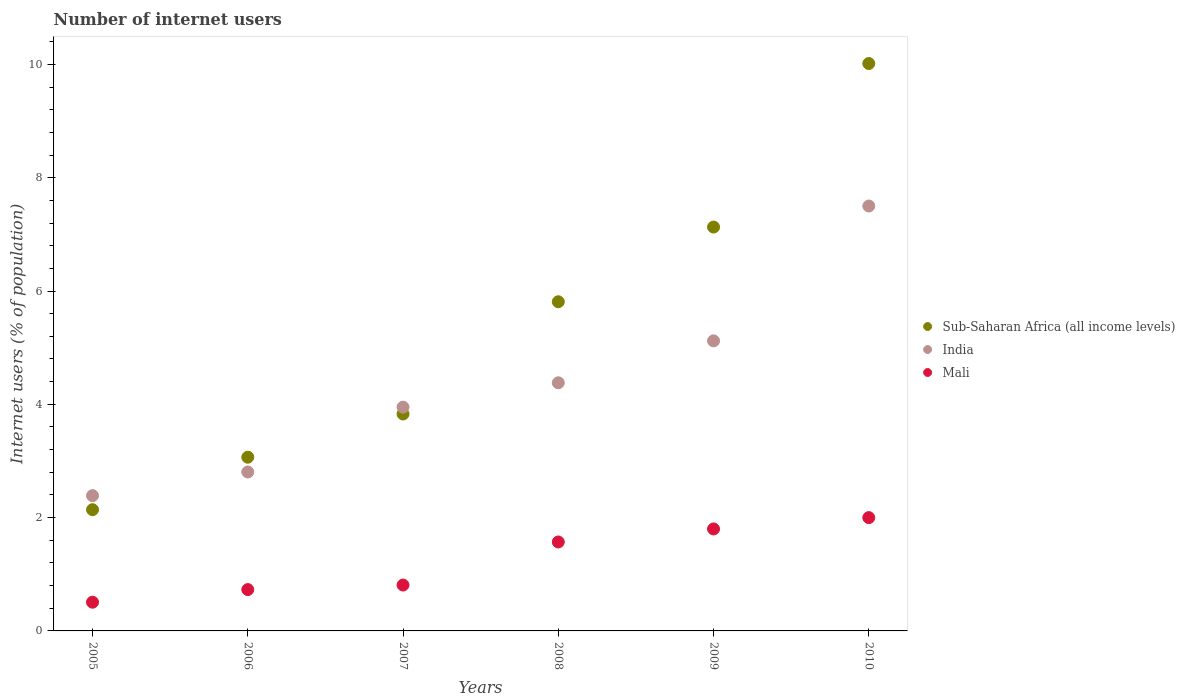How many different coloured dotlines are there?
Ensure brevity in your answer.  3. Is the number of dotlines equal to the number of legend labels?
Offer a very short reply. Yes. What is the number of internet users in India in 2005?
Offer a very short reply. 2.39. Across all years, what is the maximum number of internet users in Sub-Saharan Africa (all income levels)?
Give a very brief answer. 10.02. Across all years, what is the minimum number of internet users in Sub-Saharan Africa (all income levels)?
Your answer should be compact. 2.14. In which year was the number of internet users in Sub-Saharan Africa (all income levels) maximum?
Your answer should be very brief. 2010. In which year was the number of internet users in India minimum?
Your answer should be very brief. 2005. What is the total number of internet users in India in the graph?
Your response must be concise. 26.14. What is the difference between the number of internet users in India in 2009 and that in 2010?
Give a very brief answer. -2.38. What is the difference between the number of internet users in Mali in 2005 and the number of internet users in India in 2009?
Provide a succinct answer. -4.61. What is the average number of internet users in India per year?
Your answer should be compact. 4.36. In the year 2006, what is the difference between the number of internet users in India and number of internet users in Sub-Saharan Africa (all income levels)?
Make the answer very short. -0.26. What is the ratio of the number of internet users in Sub-Saharan Africa (all income levels) in 2006 to that in 2008?
Provide a short and direct response. 0.53. Is the number of internet users in Mali in 2006 less than that in 2010?
Make the answer very short. Yes. What is the difference between the highest and the second highest number of internet users in Sub-Saharan Africa (all income levels)?
Make the answer very short. 2.89. What is the difference between the highest and the lowest number of internet users in Mali?
Your answer should be very brief. 1.49. Is the sum of the number of internet users in Sub-Saharan Africa (all income levels) in 2008 and 2009 greater than the maximum number of internet users in Mali across all years?
Provide a succinct answer. Yes. Does the number of internet users in Sub-Saharan Africa (all income levels) monotonically increase over the years?
Your answer should be compact. Yes. Are the values on the major ticks of Y-axis written in scientific E-notation?
Keep it short and to the point. No. Does the graph contain any zero values?
Keep it short and to the point. No. Where does the legend appear in the graph?
Your response must be concise. Center right. How many legend labels are there?
Provide a short and direct response. 3. How are the legend labels stacked?
Your response must be concise. Vertical. What is the title of the graph?
Provide a succinct answer. Number of internet users. Does "Samoa" appear as one of the legend labels in the graph?
Provide a short and direct response. No. What is the label or title of the X-axis?
Your response must be concise. Years. What is the label or title of the Y-axis?
Your response must be concise. Internet users (% of population). What is the Internet users (% of population) in Sub-Saharan Africa (all income levels) in 2005?
Ensure brevity in your answer.  2.14. What is the Internet users (% of population) of India in 2005?
Give a very brief answer. 2.39. What is the Internet users (% of population) of Mali in 2005?
Your answer should be very brief. 0.51. What is the Internet users (% of population) in Sub-Saharan Africa (all income levels) in 2006?
Offer a terse response. 3.07. What is the Internet users (% of population) in India in 2006?
Keep it short and to the point. 2.81. What is the Internet users (% of population) in Mali in 2006?
Make the answer very short. 0.73. What is the Internet users (% of population) in Sub-Saharan Africa (all income levels) in 2007?
Ensure brevity in your answer.  3.83. What is the Internet users (% of population) in India in 2007?
Make the answer very short. 3.95. What is the Internet users (% of population) of Mali in 2007?
Provide a succinct answer. 0.81. What is the Internet users (% of population) in Sub-Saharan Africa (all income levels) in 2008?
Ensure brevity in your answer.  5.81. What is the Internet users (% of population) of India in 2008?
Your answer should be very brief. 4.38. What is the Internet users (% of population) in Mali in 2008?
Ensure brevity in your answer.  1.57. What is the Internet users (% of population) in Sub-Saharan Africa (all income levels) in 2009?
Ensure brevity in your answer.  7.13. What is the Internet users (% of population) in India in 2009?
Offer a terse response. 5.12. What is the Internet users (% of population) of Sub-Saharan Africa (all income levels) in 2010?
Provide a short and direct response. 10.02. What is the Internet users (% of population) in Mali in 2010?
Ensure brevity in your answer.  2. Across all years, what is the maximum Internet users (% of population) in Sub-Saharan Africa (all income levels)?
Your answer should be compact. 10.02. Across all years, what is the minimum Internet users (% of population) in Sub-Saharan Africa (all income levels)?
Your answer should be very brief. 2.14. Across all years, what is the minimum Internet users (% of population) in India?
Your answer should be compact. 2.39. Across all years, what is the minimum Internet users (% of population) of Mali?
Offer a terse response. 0.51. What is the total Internet users (% of population) of Sub-Saharan Africa (all income levels) in the graph?
Your response must be concise. 31.99. What is the total Internet users (% of population) of India in the graph?
Offer a very short reply. 26.14. What is the total Internet users (% of population) of Mali in the graph?
Keep it short and to the point. 7.42. What is the difference between the Internet users (% of population) in Sub-Saharan Africa (all income levels) in 2005 and that in 2006?
Provide a short and direct response. -0.93. What is the difference between the Internet users (% of population) of India in 2005 and that in 2006?
Your response must be concise. -0.42. What is the difference between the Internet users (% of population) of Mali in 2005 and that in 2006?
Ensure brevity in your answer.  -0.22. What is the difference between the Internet users (% of population) in Sub-Saharan Africa (all income levels) in 2005 and that in 2007?
Provide a succinct answer. -1.69. What is the difference between the Internet users (% of population) in India in 2005 and that in 2007?
Your answer should be very brief. -1.56. What is the difference between the Internet users (% of population) of Mali in 2005 and that in 2007?
Keep it short and to the point. -0.3. What is the difference between the Internet users (% of population) in Sub-Saharan Africa (all income levels) in 2005 and that in 2008?
Give a very brief answer. -3.67. What is the difference between the Internet users (% of population) in India in 2005 and that in 2008?
Make the answer very short. -1.99. What is the difference between the Internet users (% of population) in Mali in 2005 and that in 2008?
Make the answer very short. -1.06. What is the difference between the Internet users (% of population) of Sub-Saharan Africa (all income levels) in 2005 and that in 2009?
Your response must be concise. -4.99. What is the difference between the Internet users (% of population) in India in 2005 and that in 2009?
Ensure brevity in your answer.  -2.73. What is the difference between the Internet users (% of population) in Mali in 2005 and that in 2009?
Offer a terse response. -1.29. What is the difference between the Internet users (% of population) in Sub-Saharan Africa (all income levels) in 2005 and that in 2010?
Your answer should be very brief. -7.88. What is the difference between the Internet users (% of population) of India in 2005 and that in 2010?
Give a very brief answer. -5.11. What is the difference between the Internet users (% of population) in Mali in 2005 and that in 2010?
Give a very brief answer. -1.49. What is the difference between the Internet users (% of population) of Sub-Saharan Africa (all income levels) in 2006 and that in 2007?
Your answer should be compact. -0.76. What is the difference between the Internet users (% of population) of India in 2006 and that in 2007?
Provide a succinct answer. -1.14. What is the difference between the Internet users (% of population) in Mali in 2006 and that in 2007?
Give a very brief answer. -0.08. What is the difference between the Internet users (% of population) in Sub-Saharan Africa (all income levels) in 2006 and that in 2008?
Your answer should be compact. -2.74. What is the difference between the Internet users (% of population) in India in 2006 and that in 2008?
Keep it short and to the point. -1.57. What is the difference between the Internet users (% of population) of Mali in 2006 and that in 2008?
Offer a terse response. -0.84. What is the difference between the Internet users (% of population) of Sub-Saharan Africa (all income levels) in 2006 and that in 2009?
Ensure brevity in your answer.  -4.06. What is the difference between the Internet users (% of population) of India in 2006 and that in 2009?
Give a very brief answer. -2.31. What is the difference between the Internet users (% of population) of Mali in 2006 and that in 2009?
Provide a succinct answer. -1.07. What is the difference between the Internet users (% of population) in Sub-Saharan Africa (all income levels) in 2006 and that in 2010?
Your answer should be very brief. -6.95. What is the difference between the Internet users (% of population) of India in 2006 and that in 2010?
Provide a short and direct response. -4.69. What is the difference between the Internet users (% of population) in Mali in 2006 and that in 2010?
Offer a very short reply. -1.27. What is the difference between the Internet users (% of population) of Sub-Saharan Africa (all income levels) in 2007 and that in 2008?
Your answer should be very brief. -1.98. What is the difference between the Internet users (% of population) in India in 2007 and that in 2008?
Provide a succinct answer. -0.43. What is the difference between the Internet users (% of population) in Mali in 2007 and that in 2008?
Your answer should be very brief. -0.76. What is the difference between the Internet users (% of population) in Sub-Saharan Africa (all income levels) in 2007 and that in 2009?
Ensure brevity in your answer.  -3.3. What is the difference between the Internet users (% of population) of India in 2007 and that in 2009?
Provide a short and direct response. -1.17. What is the difference between the Internet users (% of population) of Mali in 2007 and that in 2009?
Make the answer very short. -0.99. What is the difference between the Internet users (% of population) of Sub-Saharan Africa (all income levels) in 2007 and that in 2010?
Ensure brevity in your answer.  -6.19. What is the difference between the Internet users (% of population) in India in 2007 and that in 2010?
Provide a succinct answer. -3.55. What is the difference between the Internet users (% of population) of Mali in 2007 and that in 2010?
Offer a terse response. -1.19. What is the difference between the Internet users (% of population) in Sub-Saharan Africa (all income levels) in 2008 and that in 2009?
Ensure brevity in your answer.  -1.32. What is the difference between the Internet users (% of population) in India in 2008 and that in 2009?
Your answer should be very brief. -0.74. What is the difference between the Internet users (% of population) in Mali in 2008 and that in 2009?
Make the answer very short. -0.23. What is the difference between the Internet users (% of population) of Sub-Saharan Africa (all income levels) in 2008 and that in 2010?
Your answer should be very brief. -4.21. What is the difference between the Internet users (% of population) in India in 2008 and that in 2010?
Your answer should be very brief. -3.12. What is the difference between the Internet users (% of population) in Mali in 2008 and that in 2010?
Your answer should be compact. -0.43. What is the difference between the Internet users (% of population) in Sub-Saharan Africa (all income levels) in 2009 and that in 2010?
Make the answer very short. -2.89. What is the difference between the Internet users (% of population) in India in 2009 and that in 2010?
Provide a short and direct response. -2.38. What is the difference between the Internet users (% of population) in Mali in 2009 and that in 2010?
Ensure brevity in your answer.  -0.2. What is the difference between the Internet users (% of population) of Sub-Saharan Africa (all income levels) in 2005 and the Internet users (% of population) of India in 2006?
Keep it short and to the point. -0.67. What is the difference between the Internet users (% of population) in Sub-Saharan Africa (all income levels) in 2005 and the Internet users (% of population) in Mali in 2006?
Your answer should be compact. 1.41. What is the difference between the Internet users (% of population) of India in 2005 and the Internet users (% of population) of Mali in 2006?
Provide a succinct answer. 1.66. What is the difference between the Internet users (% of population) of Sub-Saharan Africa (all income levels) in 2005 and the Internet users (% of population) of India in 2007?
Your answer should be very brief. -1.81. What is the difference between the Internet users (% of population) of Sub-Saharan Africa (all income levels) in 2005 and the Internet users (% of population) of Mali in 2007?
Your response must be concise. 1.33. What is the difference between the Internet users (% of population) of India in 2005 and the Internet users (% of population) of Mali in 2007?
Ensure brevity in your answer.  1.58. What is the difference between the Internet users (% of population) in Sub-Saharan Africa (all income levels) in 2005 and the Internet users (% of population) in India in 2008?
Ensure brevity in your answer.  -2.24. What is the difference between the Internet users (% of population) in Sub-Saharan Africa (all income levels) in 2005 and the Internet users (% of population) in Mali in 2008?
Give a very brief answer. 0.57. What is the difference between the Internet users (% of population) in India in 2005 and the Internet users (% of population) in Mali in 2008?
Make the answer very short. 0.82. What is the difference between the Internet users (% of population) of Sub-Saharan Africa (all income levels) in 2005 and the Internet users (% of population) of India in 2009?
Make the answer very short. -2.98. What is the difference between the Internet users (% of population) in Sub-Saharan Africa (all income levels) in 2005 and the Internet users (% of population) in Mali in 2009?
Provide a succinct answer. 0.34. What is the difference between the Internet users (% of population) of India in 2005 and the Internet users (% of population) of Mali in 2009?
Provide a short and direct response. 0.59. What is the difference between the Internet users (% of population) of Sub-Saharan Africa (all income levels) in 2005 and the Internet users (% of population) of India in 2010?
Your response must be concise. -5.36. What is the difference between the Internet users (% of population) of Sub-Saharan Africa (all income levels) in 2005 and the Internet users (% of population) of Mali in 2010?
Provide a short and direct response. 0.14. What is the difference between the Internet users (% of population) in India in 2005 and the Internet users (% of population) in Mali in 2010?
Provide a succinct answer. 0.39. What is the difference between the Internet users (% of population) of Sub-Saharan Africa (all income levels) in 2006 and the Internet users (% of population) of India in 2007?
Provide a short and direct response. -0.88. What is the difference between the Internet users (% of population) in Sub-Saharan Africa (all income levels) in 2006 and the Internet users (% of population) in Mali in 2007?
Keep it short and to the point. 2.26. What is the difference between the Internet users (% of population) of India in 2006 and the Internet users (% of population) of Mali in 2007?
Ensure brevity in your answer.  2. What is the difference between the Internet users (% of population) of Sub-Saharan Africa (all income levels) in 2006 and the Internet users (% of population) of India in 2008?
Your answer should be very brief. -1.31. What is the difference between the Internet users (% of population) in Sub-Saharan Africa (all income levels) in 2006 and the Internet users (% of population) in Mali in 2008?
Provide a succinct answer. 1.5. What is the difference between the Internet users (% of population) of India in 2006 and the Internet users (% of population) of Mali in 2008?
Keep it short and to the point. 1.24. What is the difference between the Internet users (% of population) in Sub-Saharan Africa (all income levels) in 2006 and the Internet users (% of population) in India in 2009?
Give a very brief answer. -2.05. What is the difference between the Internet users (% of population) of Sub-Saharan Africa (all income levels) in 2006 and the Internet users (% of population) of Mali in 2009?
Keep it short and to the point. 1.27. What is the difference between the Internet users (% of population) in Sub-Saharan Africa (all income levels) in 2006 and the Internet users (% of population) in India in 2010?
Offer a very short reply. -4.43. What is the difference between the Internet users (% of population) in Sub-Saharan Africa (all income levels) in 2006 and the Internet users (% of population) in Mali in 2010?
Ensure brevity in your answer.  1.07. What is the difference between the Internet users (% of population) in India in 2006 and the Internet users (% of population) in Mali in 2010?
Offer a terse response. 0.81. What is the difference between the Internet users (% of population) of Sub-Saharan Africa (all income levels) in 2007 and the Internet users (% of population) of India in 2008?
Your response must be concise. -0.55. What is the difference between the Internet users (% of population) in Sub-Saharan Africa (all income levels) in 2007 and the Internet users (% of population) in Mali in 2008?
Keep it short and to the point. 2.26. What is the difference between the Internet users (% of population) in India in 2007 and the Internet users (% of population) in Mali in 2008?
Offer a very short reply. 2.38. What is the difference between the Internet users (% of population) in Sub-Saharan Africa (all income levels) in 2007 and the Internet users (% of population) in India in 2009?
Make the answer very short. -1.29. What is the difference between the Internet users (% of population) of Sub-Saharan Africa (all income levels) in 2007 and the Internet users (% of population) of Mali in 2009?
Provide a succinct answer. 2.03. What is the difference between the Internet users (% of population) in India in 2007 and the Internet users (% of population) in Mali in 2009?
Make the answer very short. 2.15. What is the difference between the Internet users (% of population) in Sub-Saharan Africa (all income levels) in 2007 and the Internet users (% of population) in India in 2010?
Provide a succinct answer. -3.67. What is the difference between the Internet users (% of population) in Sub-Saharan Africa (all income levels) in 2007 and the Internet users (% of population) in Mali in 2010?
Your response must be concise. 1.83. What is the difference between the Internet users (% of population) of India in 2007 and the Internet users (% of population) of Mali in 2010?
Offer a terse response. 1.95. What is the difference between the Internet users (% of population) in Sub-Saharan Africa (all income levels) in 2008 and the Internet users (% of population) in India in 2009?
Provide a short and direct response. 0.69. What is the difference between the Internet users (% of population) in Sub-Saharan Africa (all income levels) in 2008 and the Internet users (% of population) in Mali in 2009?
Provide a short and direct response. 4.01. What is the difference between the Internet users (% of population) of India in 2008 and the Internet users (% of population) of Mali in 2009?
Your answer should be very brief. 2.58. What is the difference between the Internet users (% of population) in Sub-Saharan Africa (all income levels) in 2008 and the Internet users (% of population) in India in 2010?
Provide a short and direct response. -1.69. What is the difference between the Internet users (% of population) in Sub-Saharan Africa (all income levels) in 2008 and the Internet users (% of population) in Mali in 2010?
Offer a very short reply. 3.81. What is the difference between the Internet users (% of population) of India in 2008 and the Internet users (% of population) of Mali in 2010?
Keep it short and to the point. 2.38. What is the difference between the Internet users (% of population) in Sub-Saharan Africa (all income levels) in 2009 and the Internet users (% of population) in India in 2010?
Provide a succinct answer. -0.37. What is the difference between the Internet users (% of population) in Sub-Saharan Africa (all income levels) in 2009 and the Internet users (% of population) in Mali in 2010?
Keep it short and to the point. 5.13. What is the difference between the Internet users (% of population) of India in 2009 and the Internet users (% of population) of Mali in 2010?
Provide a succinct answer. 3.12. What is the average Internet users (% of population) in Sub-Saharan Africa (all income levels) per year?
Make the answer very short. 5.33. What is the average Internet users (% of population) in India per year?
Your answer should be very brief. 4.36. What is the average Internet users (% of population) in Mali per year?
Offer a very short reply. 1.24. In the year 2005, what is the difference between the Internet users (% of population) in Sub-Saharan Africa (all income levels) and Internet users (% of population) in India?
Give a very brief answer. -0.25. In the year 2005, what is the difference between the Internet users (% of population) in Sub-Saharan Africa (all income levels) and Internet users (% of population) in Mali?
Make the answer very short. 1.63. In the year 2005, what is the difference between the Internet users (% of population) in India and Internet users (% of population) in Mali?
Your answer should be compact. 1.88. In the year 2006, what is the difference between the Internet users (% of population) in Sub-Saharan Africa (all income levels) and Internet users (% of population) in India?
Give a very brief answer. 0.26. In the year 2006, what is the difference between the Internet users (% of population) of Sub-Saharan Africa (all income levels) and Internet users (% of population) of Mali?
Make the answer very short. 2.34. In the year 2006, what is the difference between the Internet users (% of population) of India and Internet users (% of population) of Mali?
Offer a very short reply. 2.08. In the year 2007, what is the difference between the Internet users (% of population) in Sub-Saharan Africa (all income levels) and Internet users (% of population) in India?
Give a very brief answer. -0.12. In the year 2007, what is the difference between the Internet users (% of population) in Sub-Saharan Africa (all income levels) and Internet users (% of population) in Mali?
Make the answer very short. 3.02. In the year 2007, what is the difference between the Internet users (% of population) of India and Internet users (% of population) of Mali?
Offer a very short reply. 3.14. In the year 2008, what is the difference between the Internet users (% of population) of Sub-Saharan Africa (all income levels) and Internet users (% of population) of India?
Your response must be concise. 1.43. In the year 2008, what is the difference between the Internet users (% of population) of Sub-Saharan Africa (all income levels) and Internet users (% of population) of Mali?
Offer a terse response. 4.24. In the year 2008, what is the difference between the Internet users (% of population) of India and Internet users (% of population) of Mali?
Ensure brevity in your answer.  2.81. In the year 2009, what is the difference between the Internet users (% of population) of Sub-Saharan Africa (all income levels) and Internet users (% of population) of India?
Provide a short and direct response. 2.01. In the year 2009, what is the difference between the Internet users (% of population) in Sub-Saharan Africa (all income levels) and Internet users (% of population) in Mali?
Give a very brief answer. 5.33. In the year 2009, what is the difference between the Internet users (% of population) of India and Internet users (% of population) of Mali?
Your answer should be very brief. 3.32. In the year 2010, what is the difference between the Internet users (% of population) in Sub-Saharan Africa (all income levels) and Internet users (% of population) in India?
Ensure brevity in your answer.  2.52. In the year 2010, what is the difference between the Internet users (% of population) of Sub-Saharan Africa (all income levels) and Internet users (% of population) of Mali?
Your response must be concise. 8.02. What is the ratio of the Internet users (% of population) of Sub-Saharan Africa (all income levels) in 2005 to that in 2006?
Provide a short and direct response. 0.7. What is the ratio of the Internet users (% of population) of India in 2005 to that in 2006?
Your response must be concise. 0.85. What is the ratio of the Internet users (% of population) of Mali in 2005 to that in 2006?
Your response must be concise. 0.69. What is the ratio of the Internet users (% of population) of Sub-Saharan Africa (all income levels) in 2005 to that in 2007?
Keep it short and to the point. 0.56. What is the ratio of the Internet users (% of population) in India in 2005 to that in 2007?
Your answer should be compact. 0.6. What is the ratio of the Internet users (% of population) in Mali in 2005 to that in 2007?
Keep it short and to the point. 0.63. What is the ratio of the Internet users (% of population) of Sub-Saharan Africa (all income levels) in 2005 to that in 2008?
Your answer should be compact. 0.37. What is the ratio of the Internet users (% of population) in India in 2005 to that in 2008?
Provide a short and direct response. 0.55. What is the ratio of the Internet users (% of population) of Mali in 2005 to that in 2008?
Offer a terse response. 0.32. What is the ratio of the Internet users (% of population) in Sub-Saharan Africa (all income levels) in 2005 to that in 2009?
Ensure brevity in your answer.  0.3. What is the ratio of the Internet users (% of population) in India in 2005 to that in 2009?
Provide a succinct answer. 0.47. What is the ratio of the Internet users (% of population) of Mali in 2005 to that in 2009?
Ensure brevity in your answer.  0.28. What is the ratio of the Internet users (% of population) in Sub-Saharan Africa (all income levels) in 2005 to that in 2010?
Offer a very short reply. 0.21. What is the ratio of the Internet users (% of population) of India in 2005 to that in 2010?
Make the answer very short. 0.32. What is the ratio of the Internet users (% of population) in Mali in 2005 to that in 2010?
Your answer should be very brief. 0.25. What is the ratio of the Internet users (% of population) of Sub-Saharan Africa (all income levels) in 2006 to that in 2007?
Provide a short and direct response. 0.8. What is the ratio of the Internet users (% of population) in India in 2006 to that in 2007?
Provide a short and direct response. 0.71. What is the ratio of the Internet users (% of population) in Mali in 2006 to that in 2007?
Keep it short and to the point. 0.9. What is the ratio of the Internet users (% of population) of Sub-Saharan Africa (all income levels) in 2006 to that in 2008?
Keep it short and to the point. 0.53. What is the ratio of the Internet users (% of population) of India in 2006 to that in 2008?
Provide a succinct answer. 0.64. What is the ratio of the Internet users (% of population) in Mali in 2006 to that in 2008?
Offer a terse response. 0.46. What is the ratio of the Internet users (% of population) in Sub-Saharan Africa (all income levels) in 2006 to that in 2009?
Make the answer very short. 0.43. What is the ratio of the Internet users (% of population) in India in 2006 to that in 2009?
Your response must be concise. 0.55. What is the ratio of the Internet users (% of population) in Mali in 2006 to that in 2009?
Provide a succinct answer. 0.41. What is the ratio of the Internet users (% of population) in Sub-Saharan Africa (all income levels) in 2006 to that in 2010?
Give a very brief answer. 0.31. What is the ratio of the Internet users (% of population) in India in 2006 to that in 2010?
Ensure brevity in your answer.  0.37. What is the ratio of the Internet users (% of population) in Mali in 2006 to that in 2010?
Give a very brief answer. 0.36. What is the ratio of the Internet users (% of population) in Sub-Saharan Africa (all income levels) in 2007 to that in 2008?
Make the answer very short. 0.66. What is the ratio of the Internet users (% of population) of India in 2007 to that in 2008?
Provide a short and direct response. 0.9. What is the ratio of the Internet users (% of population) in Mali in 2007 to that in 2008?
Ensure brevity in your answer.  0.52. What is the ratio of the Internet users (% of population) of Sub-Saharan Africa (all income levels) in 2007 to that in 2009?
Offer a terse response. 0.54. What is the ratio of the Internet users (% of population) of India in 2007 to that in 2009?
Your answer should be very brief. 0.77. What is the ratio of the Internet users (% of population) of Mali in 2007 to that in 2009?
Offer a very short reply. 0.45. What is the ratio of the Internet users (% of population) in Sub-Saharan Africa (all income levels) in 2007 to that in 2010?
Your response must be concise. 0.38. What is the ratio of the Internet users (% of population) in India in 2007 to that in 2010?
Provide a short and direct response. 0.53. What is the ratio of the Internet users (% of population) of Mali in 2007 to that in 2010?
Your answer should be compact. 0.41. What is the ratio of the Internet users (% of population) in Sub-Saharan Africa (all income levels) in 2008 to that in 2009?
Your answer should be compact. 0.82. What is the ratio of the Internet users (% of population) in India in 2008 to that in 2009?
Your answer should be very brief. 0.86. What is the ratio of the Internet users (% of population) of Mali in 2008 to that in 2009?
Your answer should be compact. 0.87. What is the ratio of the Internet users (% of population) in Sub-Saharan Africa (all income levels) in 2008 to that in 2010?
Keep it short and to the point. 0.58. What is the ratio of the Internet users (% of population) in India in 2008 to that in 2010?
Your answer should be compact. 0.58. What is the ratio of the Internet users (% of population) in Mali in 2008 to that in 2010?
Keep it short and to the point. 0.79. What is the ratio of the Internet users (% of population) of Sub-Saharan Africa (all income levels) in 2009 to that in 2010?
Offer a very short reply. 0.71. What is the ratio of the Internet users (% of population) in India in 2009 to that in 2010?
Offer a terse response. 0.68. What is the difference between the highest and the second highest Internet users (% of population) of Sub-Saharan Africa (all income levels)?
Give a very brief answer. 2.89. What is the difference between the highest and the second highest Internet users (% of population) in India?
Offer a very short reply. 2.38. What is the difference between the highest and the lowest Internet users (% of population) in Sub-Saharan Africa (all income levels)?
Make the answer very short. 7.88. What is the difference between the highest and the lowest Internet users (% of population) of India?
Ensure brevity in your answer.  5.11. What is the difference between the highest and the lowest Internet users (% of population) of Mali?
Your answer should be very brief. 1.49. 